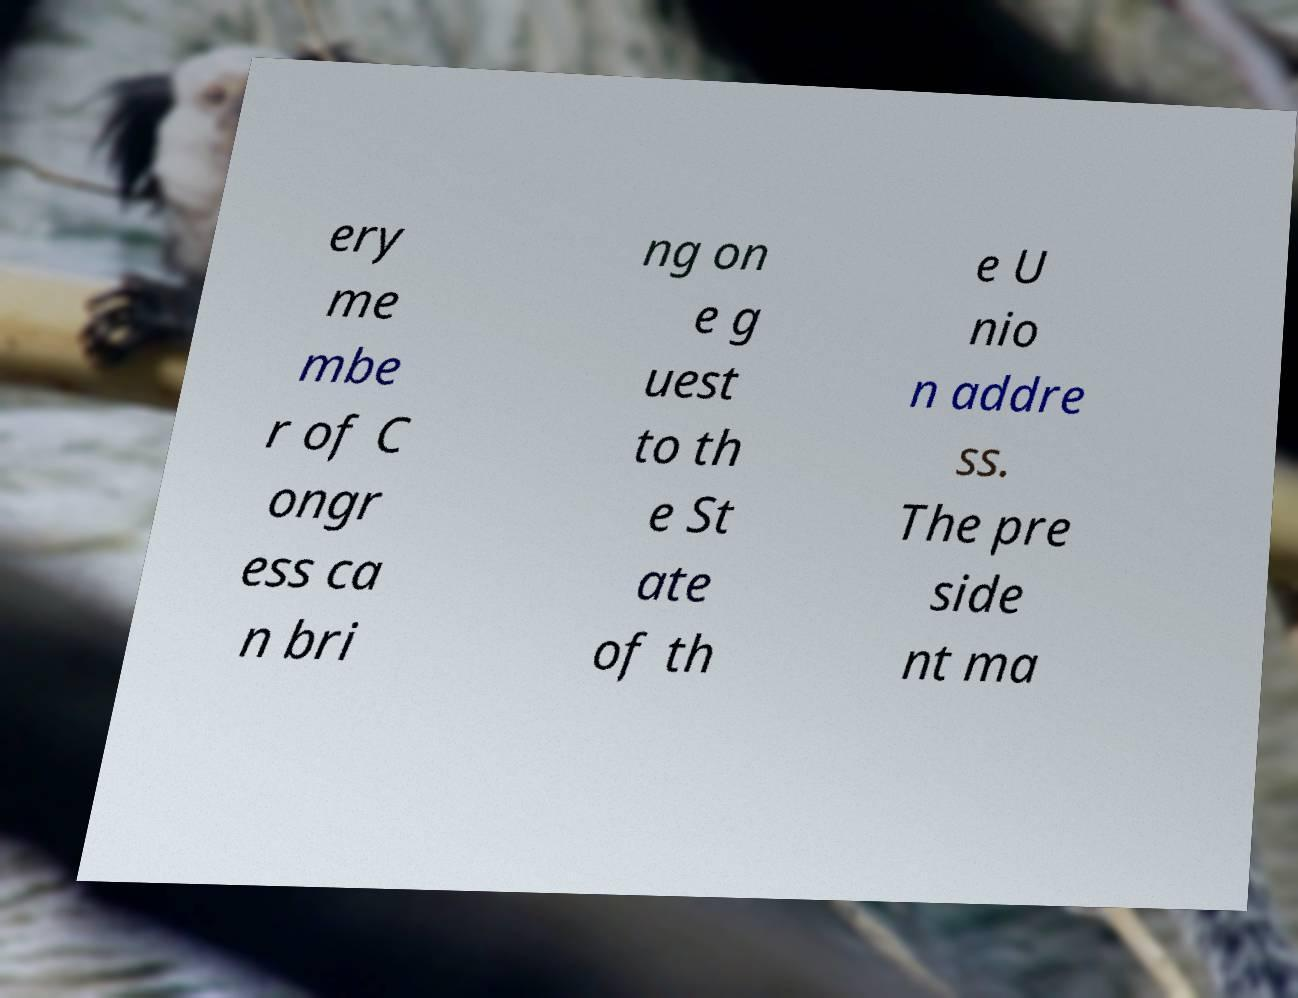Please identify and transcribe the text found in this image. ery me mbe r of C ongr ess ca n bri ng on e g uest to th e St ate of th e U nio n addre ss. The pre side nt ma 